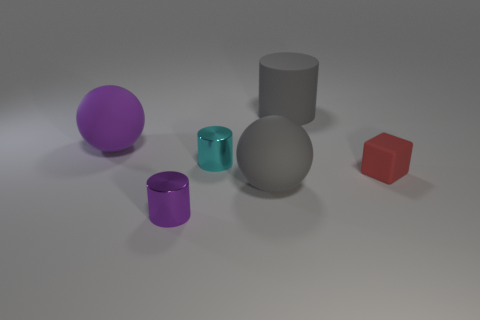Add 3 rubber cubes. How many objects exist? 9 Subtract all spheres. How many objects are left? 4 Subtract all big red rubber cylinders. Subtract all matte things. How many objects are left? 2 Add 5 purple metallic cylinders. How many purple metallic cylinders are left? 6 Add 1 large gray balls. How many large gray balls exist? 2 Subtract 0 yellow cylinders. How many objects are left? 6 